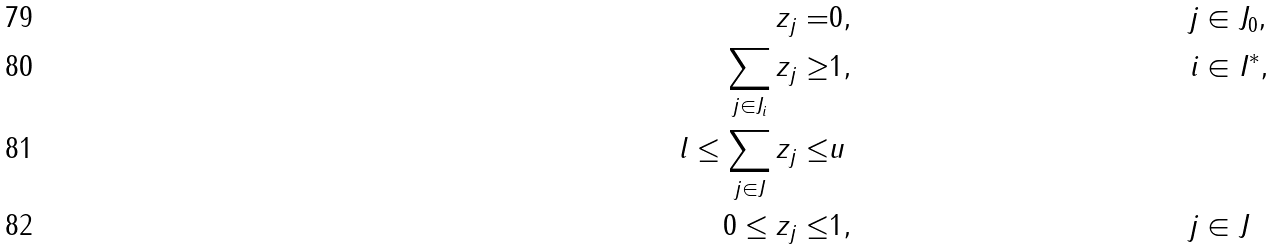Convert formula to latex. <formula><loc_0><loc_0><loc_500><loc_500>& & z _ { j } = & 0 , & j & \in J _ { 0 } , & & \\ & & \sum _ { j \in J _ { i } } z _ { j } \geq & 1 , & i & \in I ^ { * } , & & \\ & & l \leq \sum _ { j \in J } z _ { j } \leq & u & & \\ & & 0 \leq z _ { j } \leq & 1 , & j & \in J & &</formula> 